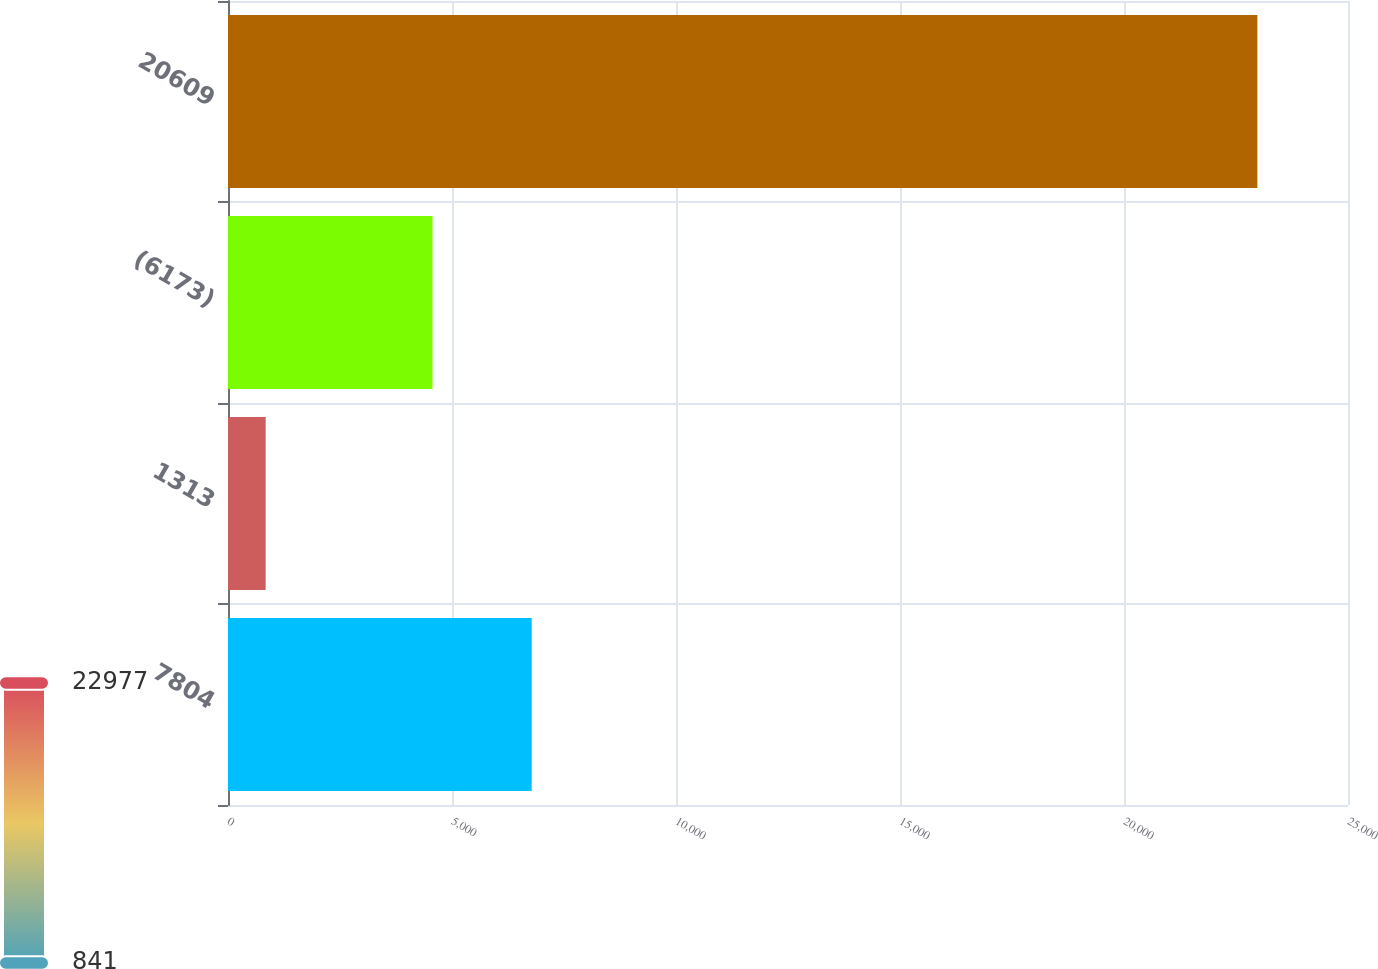Convert chart. <chart><loc_0><loc_0><loc_500><loc_500><bar_chart><fcel>7804<fcel>1313<fcel>(6173)<fcel>20609<nl><fcel>6778.6<fcel>841<fcel>4565<fcel>22977<nl></chart> 